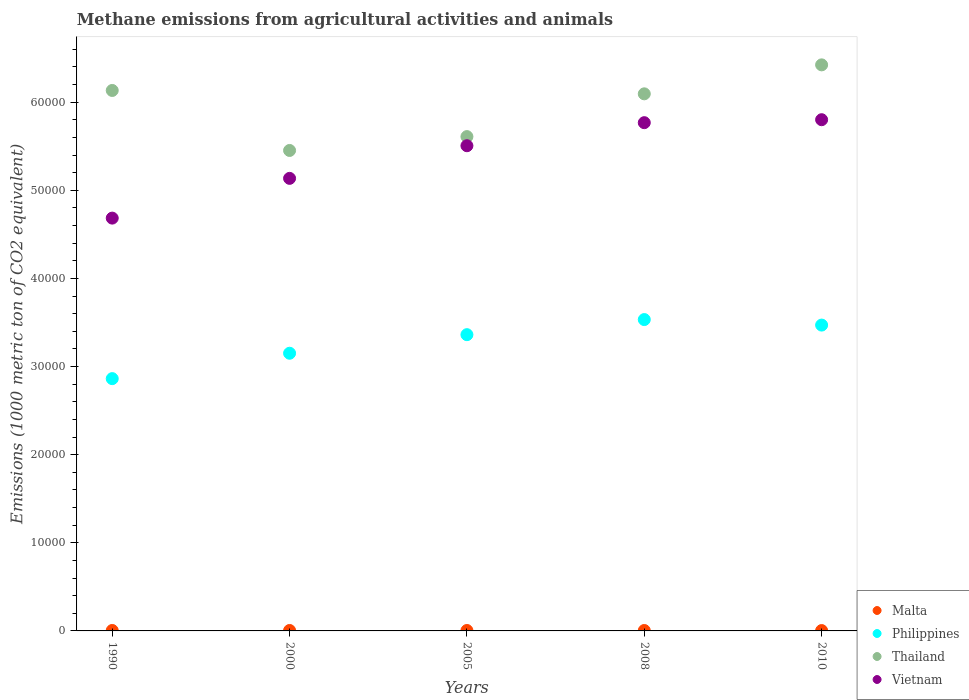How many different coloured dotlines are there?
Make the answer very short. 4. Is the number of dotlines equal to the number of legend labels?
Your answer should be very brief. Yes. What is the amount of methane emitted in Malta in 2008?
Provide a succinct answer. 46.9. Across all years, what is the maximum amount of methane emitted in Philippines?
Offer a terse response. 3.53e+04. Across all years, what is the minimum amount of methane emitted in Vietnam?
Ensure brevity in your answer.  4.68e+04. In which year was the amount of methane emitted in Philippines maximum?
Keep it short and to the point. 2008. What is the total amount of methane emitted in Philippines in the graph?
Provide a short and direct response. 1.64e+05. What is the difference between the amount of methane emitted in Vietnam in 2000 and that in 2010?
Keep it short and to the point. -6656.2. What is the difference between the amount of methane emitted in Philippines in 1990 and the amount of methane emitted in Malta in 2000?
Give a very brief answer. 2.86e+04. What is the average amount of methane emitted in Vietnam per year?
Make the answer very short. 5.38e+04. In the year 2000, what is the difference between the amount of methane emitted in Malta and amount of methane emitted in Vietnam?
Your answer should be very brief. -5.13e+04. What is the ratio of the amount of methane emitted in Malta in 1990 to that in 2008?
Keep it short and to the point. 1.09. Is the amount of methane emitted in Philippines in 1990 less than that in 2008?
Provide a succinct answer. Yes. What is the difference between the highest and the second highest amount of methane emitted in Malta?
Provide a succinct answer. 0.3. What is the difference between the highest and the lowest amount of methane emitted in Malta?
Ensure brevity in your answer.  9.9. In how many years, is the amount of methane emitted in Thailand greater than the average amount of methane emitted in Thailand taken over all years?
Make the answer very short. 3. Is the sum of the amount of methane emitted in Philippines in 1990 and 2000 greater than the maximum amount of methane emitted in Malta across all years?
Offer a very short reply. Yes. Is the amount of methane emitted in Thailand strictly greater than the amount of methane emitted in Malta over the years?
Your answer should be compact. Yes. Is the amount of methane emitted in Vietnam strictly less than the amount of methane emitted in Malta over the years?
Your response must be concise. No. How many years are there in the graph?
Keep it short and to the point. 5. Are the values on the major ticks of Y-axis written in scientific E-notation?
Make the answer very short. No. Does the graph contain any zero values?
Your answer should be compact. No. How many legend labels are there?
Give a very brief answer. 4. What is the title of the graph?
Your answer should be compact. Methane emissions from agricultural activities and animals. What is the label or title of the Y-axis?
Your answer should be compact. Emissions (1000 metric ton of CO2 equivalent). What is the Emissions (1000 metric ton of CO2 equivalent) of Malta in 1990?
Give a very brief answer. 50.9. What is the Emissions (1000 metric ton of CO2 equivalent) in Philippines in 1990?
Make the answer very short. 2.86e+04. What is the Emissions (1000 metric ton of CO2 equivalent) in Thailand in 1990?
Keep it short and to the point. 6.13e+04. What is the Emissions (1000 metric ton of CO2 equivalent) of Vietnam in 1990?
Give a very brief answer. 4.68e+04. What is the Emissions (1000 metric ton of CO2 equivalent) in Malta in 2000?
Offer a terse response. 50.6. What is the Emissions (1000 metric ton of CO2 equivalent) in Philippines in 2000?
Ensure brevity in your answer.  3.15e+04. What is the Emissions (1000 metric ton of CO2 equivalent) in Thailand in 2000?
Keep it short and to the point. 5.45e+04. What is the Emissions (1000 metric ton of CO2 equivalent) in Vietnam in 2000?
Provide a short and direct response. 5.14e+04. What is the Emissions (1000 metric ton of CO2 equivalent) of Malta in 2005?
Provide a short and direct response. 48.2. What is the Emissions (1000 metric ton of CO2 equivalent) in Philippines in 2005?
Offer a very short reply. 3.36e+04. What is the Emissions (1000 metric ton of CO2 equivalent) of Thailand in 2005?
Ensure brevity in your answer.  5.61e+04. What is the Emissions (1000 metric ton of CO2 equivalent) in Vietnam in 2005?
Your response must be concise. 5.51e+04. What is the Emissions (1000 metric ton of CO2 equivalent) in Malta in 2008?
Your response must be concise. 46.9. What is the Emissions (1000 metric ton of CO2 equivalent) of Philippines in 2008?
Offer a terse response. 3.53e+04. What is the Emissions (1000 metric ton of CO2 equivalent) in Thailand in 2008?
Give a very brief answer. 6.10e+04. What is the Emissions (1000 metric ton of CO2 equivalent) in Vietnam in 2008?
Offer a very short reply. 5.77e+04. What is the Emissions (1000 metric ton of CO2 equivalent) in Philippines in 2010?
Make the answer very short. 3.47e+04. What is the Emissions (1000 metric ton of CO2 equivalent) in Thailand in 2010?
Your response must be concise. 6.42e+04. What is the Emissions (1000 metric ton of CO2 equivalent) of Vietnam in 2010?
Keep it short and to the point. 5.80e+04. Across all years, what is the maximum Emissions (1000 metric ton of CO2 equivalent) in Malta?
Your response must be concise. 50.9. Across all years, what is the maximum Emissions (1000 metric ton of CO2 equivalent) in Philippines?
Your answer should be compact. 3.53e+04. Across all years, what is the maximum Emissions (1000 metric ton of CO2 equivalent) in Thailand?
Provide a short and direct response. 6.42e+04. Across all years, what is the maximum Emissions (1000 metric ton of CO2 equivalent) in Vietnam?
Offer a very short reply. 5.80e+04. Across all years, what is the minimum Emissions (1000 metric ton of CO2 equivalent) of Philippines?
Your response must be concise. 2.86e+04. Across all years, what is the minimum Emissions (1000 metric ton of CO2 equivalent) in Thailand?
Your answer should be compact. 5.45e+04. Across all years, what is the minimum Emissions (1000 metric ton of CO2 equivalent) in Vietnam?
Your answer should be compact. 4.68e+04. What is the total Emissions (1000 metric ton of CO2 equivalent) of Malta in the graph?
Keep it short and to the point. 237.6. What is the total Emissions (1000 metric ton of CO2 equivalent) of Philippines in the graph?
Make the answer very short. 1.64e+05. What is the total Emissions (1000 metric ton of CO2 equivalent) in Thailand in the graph?
Provide a short and direct response. 2.97e+05. What is the total Emissions (1000 metric ton of CO2 equivalent) of Vietnam in the graph?
Ensure brevity in your answer.  2.69e+05. What is the difference between the Emissions (1000 metric ton of CO2 equivalent) of Malta in 1990 and that in 2000?
Your response must be concise. 0.3. What is the difference between the Emissions (1000 metric ton of CO2 equivalent) of Philippines in 1990 and that in 2000?
Offer a very short reply. -2881.3. What is the difference between the Emissions (1000 metric ton of CO2 equivalent) of Thailand in 1990 and that in 2000?
Offer a very short reply. 6808.4. What is the difference between the Emissions (1000 metric ton of CO2 equivalent) of Vietnam in 1990 and that in 2000?
Provide a succinct answer. -4511. What is the difference between the Emissions (1000 metric ton of CO2 equivalent) of Malta in 1990 and that in 2005?
Ensure brevity in your answer.  2.7. What is the difference between the Emissions (1000 metric ton of CO2 equivalent) in Philippines in 1990 and that in 2005?
Offer a very short reply. -4989.5. What is the difference between the Emissions (1000 metric ton of CO2 equivalent) of Thailand in 1990 and that in 2005?
Offer a very short reply. 5235.2. What is the difference between the Emissions (1000 metric ton of CO2 equivalent) of Vietnam in 1990 and that in 2005?
Your response must be concise. -8213.9. What is the difference between the Emissions (1000 metric ton of CO2 equivalent) in Philippines in 1990 and that in 2008?
Your answer should be compact. -6703.2. What is the difference between the Emissions (1000 metric ton of CO2 equivalent) of Thailand in 1990 and that in 2008?
Make the answer very short. 381.9. What is the difference between the Emissions (1000 metric ton of CO2 equivalent) of Vietnam in 1990 and that in 2008?
Ensure brevity in your answer.  -1.08e+04. What is the difference between the Emissions (1000 metric ton of CO2 equivalent) in Malta in 1990 and that in 2010?
Ensure brevity in your answer.  9.9. What is the difference between the Emissions (1000 metric ton of CO2 equivalent) of Philippines in 1990 and that in 2010?
Keep it short and to the point. -6077.5. What is the difference between the Emissions (1000 metric ton of CO2 equivalent) in Thailand in 1990 and that in 2010?
Your response must be concise. -2905.8. What is the difference between the Emissions (1000 metric ton of CO2 equivalent) in Vietnam in 1990 and that in 2010?
Provide a short and direct response. -1.12e+04. What is the difference between the Emissions (1000 metric ton of CO2 equivalent) in Philippines in 2000 and that in 2005?
Make the answer very short. -2108.2. What is the difference between the Emissions (1000 metric ton of CO2 equivalent) of Thailand in 2000 and that in 2005?
Ensure brevity in your answer.  -1573.2. What is the difference between the Emissions (1000 metric ton of CO2 equivalent) of Vietnam in 2000 and that in 2005?
Your response must be concise. -3702.9. What is the difference between the Emissions (1000 metric ton of CO2 equivalent) of Philippines in 2000 and that in 2008?
Make the answer very short. -3821.9. What is the difference between the Emissions (1000 metric ton of CO2 equivalent) of Thailand in 2000 and that in 2008?
Offer a very short reply. -6426.5. What is the difference between the Emissions (1000 metric ton of CO2 equivalent) of Vietnam in 2000 and that in 2008?
Your answer should be compact. -6319.4. What is the difference between the Emissions (1000 metric ton of CO2 equivalent) in Philippines in 2000 and that in 2010?
Provide a short and direct response. -3196.2. What is the difference between the Emissions (1000 metric ton of CO2 equivalent) of Thailand in 2000 and that in 2010?
Provide a succinct answer. -9714.2. What is the difference between the Emissions (1000 metric ton of CO2 equivalent) of Vietnam in 2000 and that in 2010?
Keep it short and to the point. -6656.2. What is the difference between the Emissions (1000 metric ton of CO2 equivalent) of Philippines in 2005 and that in 2008?
Provide a short and direct response. -1713.7. What is the difference between the Emissions (1000 metric ton of CO2 equivalent) in Thailand in 2005 and that in 2008?
Give a very brief answer. -4853.3. What is the difference between the Emissions (1000 metric ton of CO2 equivalent) in Vietnam in 2005 and that in 2008?
Offer a very short reply. -2616.5. What is the difference between the Emissions (1000 metric ton of CO2 equivalent) in Philippines in 2005 and that in 2010?
Offer a terse response. -1088. What is the difference between the Emissions (1000 metric ton of CO2 equivalent) in Thailand in 2005 and that in 2010?
Your response must be concise. -8141. What is the difference between the Emissions (1000 metric ton of CO2 equivalent) of Vietnam in 2005 and that in 2010?
Your response must be concise. -2953.3. What is the difference between the Emissions (1000 metric ton of CO2 equivalent) of Philippines in 2008 and that in 2010?
Make the answer very short. 625.7. What is the difference between the Emissions (1000 metric ton of CO2 equivalent) of Thailand in 2008 and that in 2010?
Offer a very short reply. -3287.7. What is the difference between the Emissions (1000 metric ton of CO2 equivalent) of Vietnam in 2008 and that in 2010?
Provide a succinct answer. -336.8. What is the difference between the Emissions (1000 metric ton of CO2 equivalent) in Malta in 1990 and the Emissions (1000 metric ton of CO2 equivalent) in Philippines in 2000?
Your response must be concise. -3.15e+04. What is the difference between the Emissions (1000 metric ton of CO2 equivalent) of Malta in 1990 and the Emissions (1000 metric ton of CO2 equivalent) of Thailand in 2000?
Give a very brief answer. -5.45e+04. What is the difference between the Emissions (1000 metric ton of CO2 equivalent) of Malta in 1990 and the Emissions (1000 metric ton of CO2 equivalent) of Vietnam in 2000?
Provide a succinct answer. -5.13e+04. What is the difference between the Emissions (1000 metric ton of CO2 equivalent) in Philippines in 1990 and the Emissions (1000 metric ton of CO2 equivalent) in Thailand in 2000?
Make the answer very short. -2.59e+04. What is the difference between the Emissions (1000 metric ton of CO2 equivalent) in Philippines in 1990 and the Emissions (1000 metric ton of CO2 equivalent) in Vietnam in 2000?
Give a very brief answer. -2.27e+04. What is the difference between the Emissions (1000 metric ton of CO2 equivalent) in Thailand in 1990 and the Emissions (1000 metric ton of CO2 equivalent) in Vietnam in 2000?
Offer a terse response. 9974.7. What is the difference between the Emissions (1000 metric ton of CO2 equivalent) in Malta in 1990 and the Emissions (1000 metric ton of CO2 equivalent) in Philippines in 2005?
Provide a short and direct response. -3.36e+04. What is the difference between the Emissions (1000 metric ton of CO2 equivalent) in Malta in 1990 and the Emissions (1000 metric ton of CO2 equivalent) in Thailand in 2005?
Your answer should be compact. -5.60e+04. What is the difference between the Emissions (1000 metric ton of CO2 equivalent) of Malta in 1990 and the Emissions (1000 metric ton of CO2 equivalent) of Vietnam in 2005?
Provide a succinct answer. -5.50e+04. What is the difference between the Emissions (1000 metric ton of CO2 equivalent) of Philippines in 1990 and the Emissions (1000 metric ton of CO2 equivalent) of Thailand in 2005?
Offer a terse response. -2.75e+04. What is the difference between the Emissions (1000 metric ton of CO2 equivalent) in Philippines in 1990 and the Emissions (1000 metric ton of CO2 equivalent) in Vietnam in 2005?
Your answer should be very brief. -2.64e+04. What is the difference between the Emissions (1000 metric ton of CO2 equivalent) in Thailand in 1990 and the Emissions (1000 metric ton of CO2 equivalent) in Vietnam in 2005?
Offer a terse response. 6271.8. What is the difference between the Emissions (1000 metric ton of CO2 equivalent) of Malta in 1990 and the Emissions (1000 metric ton of CO2 equivalent) of Philippines in 2008?
Your response must be concise. -3.53e+04. What is the difference between the Emissions (1000 metric ton of CO2 equivalent) of Malta in 1990 and the Emissions (1000 metric ton of CO2 equivalent) of Thailand in 2008?
Ensure brevity in your answer.  -6.09e+04. What is the difference between the Emissions (1000 metric ton of CO2 equivalent) in Malta in 1990 and the Emissions (1000 metric ton of CO2 equivalent) in Vietnam in 2008?
Provide a succinct answer. -5.76e+04. What is the difference between the Emissions (1000 metric ton of CO2 equivalent) of Philippines in 1990 and the Emissions (1000 metric ton of CO2 equivalent) of Thailand in 2008?
Provide a succinct answer. -3.23e+04. What is the difference between the Emissions (1000 metric ton of CO2 equivalent) in Philippines in 1990 and the Emissions (1000 metric ton of CO2 equivalent) in Vietnam in 2008?
Keep it short and to the point. -2.90e+04. What is the difference between the Emissions (1000 metric ton of CO2 equivalent) in Thailand in 1990 and the Emissions (1000 metric ton of CO2 equivalent) in Vietnam in 2008?
Offer a very short reply. 3655.3. What is the difference between the Emissions (1000 metric ton of CO2 equivalent) of Malta in 1990 and the Emissions (1000 metric ton of CO2 equivalent) of Philippines in 2010?
Ensure brevity in your answer.  -3.47e+04. What is the difference between the Emissions (1000 metric ton of CO2 equivalent) in Malta in 1990 and the Emissions (1000 metric ton of CO2 equivalent) in Thailand in 2010?
Offer a terse response. -6.42e+04. What is the difference between the Emissions (1000 metric ton of CO2 equivalent) in Malta in 1990 and the Emissions (1000 metric ton of CO2 equivalent) in Vietnam in 2010?
Your response must be concise. -5.80e+04. What is the difference between the Emissions (1000 metric ton of CO2 equivalent) in Philippines in 1990 and the Emissions (1000 metric ton of CO2 equivalent) in Thailand in 2010?
Your answer should be very brief. -3.56e+04. What is the difference between the Emissions (1000 metric ton of CO2 equivalent) of Philippines in 1990 and the Emissions (1000 metric ton of CO2 equivalent) of Vietnam in 2010?
Your answer should be compact. -2.94e+04. What is the difference between the Emissions (1000 metric ton of CO2 equivalent) in Thailand in 1990 and the Emissions (1000 metric ton of CO2 equivalent) in Vietnam in 2010?
Offer a very short reply. 3318.5. What is the difference between the Emissions (1000 metric ton of CO2 equivalent) in Malta in 2000 and the Emissions (1000 metric ton of CO2 equivalent) in Philippines in 2005?
Offer a terse response. -3.36e+04. What is the difference between the Emissions (1000 metric ton of CO2 equivalent) of Malta in 2000 and the Emissions (1000 metric ton of CO2 equivalent) of Thailand in 2005?
Ensure brevity in your answer.  -5.60e+04. What is the difference between the Emissions (1000 metric ton of CO2 equivalent) in Malta in 2000 and the Emissions (1000 metric ton of CO2 equivalent) in Vietnam in 2005?
Provide a short and direct response. -5.50e+04. What is the difference between the Emissions (1000 metric ton of CO2 equivalent) of Philippines in 2000 and the Emissions (1000 metric ton of CO2 equivalent) of Thailand in 2005?
Make the answer very short. -2.46e+04. What is the difference between the Emissions (1000 metric ton of CO2 equivalent) in Philippines in 2000 and the Emissions (1000 metric ton of CO2 equivalent) in Vietnam in 2005?
Make the answer very short. -2.35e+04. What is the difference between the Emissions (1000 metric ton of CO2 equivalent) in Thailand in 2000 and the Emissions (1000 metric ton of CO2 equivalent) in Vietnam in 2005?
Offer a terse response. -536.6. What is the difference between the Emissions (1000 metric ton of CO2 equivalent) in Malta in 2000 and the Emissions (1000 metric ton of CO2 equivalent) in Philippines in 2008?
Offer a terse response. -3.53e+04. What is the difference between the Emissions (1000 metric ton of CO2 equivalent) of Malta in 2000 and the Emissions (1000 metric ton of CO2 equivalent) of Thailand in 2008?
Give a very brief answer. -6.09e+04. What is the difference between the Emissions (1000 metric ton of CO2 equivalent) in Malta in 2000 and the Emissions (1000 metric ton of CO2 equivalent) in Vietnam in 2008?
Give a very brief answer. -5.76e+04. What is the difference between the Emissions (1000 metric ton of CO2 equivalent) of Philippines in 2000 and the Emissions (1000 metric ton of CO2 equivalent) of Thailand in 2008?
Your answer should be compact. -2.94e+04. What is the difference between the Emissions (1000 metric ton of CO2 equivalent) in Philippines in 2000 and the Emissions (1000 metric ton of CO2 equivalent) in Vietnam in 2008?
Provide a succinct answer. -2.62e+04. What is the difference between the Emissions (1000 metric ton of CO2 equivalent) in Thailand in 2000 and the Emissions (1000 metric ton of CO2 equivalent) in Vietnam in 2008?
Give a very brief answer. -3153.1. What is the difference between the Emissions (1000 metric ton of CO2 equivalent) in Malta in 2000 and the Emissions (1000 metric ton of CO2 equivalent) in Philippines in 2010?
Provide a succinct answer. -3.47e+04. What is the difference between the Emissions (1000 metric ton of CO2 equivalent) in Malta in 2000 and the Emissions (1000 metric ton of CO2 equivalent) in Thailand in 2010?
Your answer should be compact. -6.42e+04. What is the difference between the Emissions (1000 metric ton of CO2 equivalent) of Malta in 2000 and the Emissions (1000 metric ton of CO2 equivalent) of Vietnam in 2010?
Offer a very short reply. -5.80e+04. What is the difference between the Emissions (1000 metric ton of CO2 equivalent) in Philippines in 2000 and the Emissions (1000 metric ton of CO2 equivalent) in Thailand in 2010?
Provide a succinct answer. -3.27e+04. What is the difference between the Emissions (1000 metric ton of CO2 equivalent) of Philippines in 2000 and the Emissions (1000 metric ton of CO2 equivalent) of Vietnam in 2010?
Your response must be concise. -2.65e+04. What is the difference between the Emissions (1000 metric ton of CO2 equivalent) in Thailand in 2000 and the Emissions (1000 metric ton of CO2 equivalent) in Vietnam in 2010?
Provide a succinct answer. -3489.9. What is the difference between the Emissions (1000 metric ton of CO2 equivalent) in Malta in 2005 and the Emissions (1000 metric ton of CO2 equivalent) in Philippines in 2008?
Provide a succinct answer. -3.53e+04. What is the difference between the Emissions (1000 metric ton of CO2 equivalent) of Malta in 2005 and the Emissions (1000 metric ton of CO2 equivalent) of Thailand in 2008?
Provide a succinct answer. -6.09e+04. What is the difference between the Emissions (1000 metric ton of CO2 equivalent) of Malta in 2005 and the Emissions (1000 metric ton of CO2 equivalent) of Vietnam in 2008?
Your response must be concise. -5.76e+04. What is the difference between the Emissions (1000 metric ton of CO2 equivalent) in Philippines in 2005 and the Emissions (1000 metric ton of CO2 equivalent) in Thailand in 2008?
Ensure brevity in your answer.  -2.73e+04. What is the difference between the Emissions (1000 metric ton of CO2 equivalent) in Philippines in 2005 and the Emissions (1000 metric ton of CO2 equivalent) in Vietnam in 2008?
Give a very brief answer. -2.41e+04. What is the difference between the Emissions (1000 metric ton of CO2 equivalent) in Thailand in 2005 and the Emissions (1000 metric ton of CO2 equivalent) in Vietnam in 2008?
Provide a short and direct response. -1579.9. What is the difference between the Emissions (1000 metric ton of CO2 equivalent) in Malta in 2005 and the Emissions (1000 metric ton of CO2 equivalent) in Philippines in 2010?
Provide a short and direct response. -3.47e+04. What is the difference between the Emissions (1000 metric ton of CO2 equivalent) in Malta in 2005 and the Emissions (1000 metric ton of CO2 equivalent) in Thailand in 2010?
Make the answer very short. -6.42e+04. What is the difference between the Emissions (1000 metric ton of CO2 equivalent) of Malta in 2005 and the Emissions (1000 metric ton of CO2 equivalent) of Vietnam in 2010?
Give a very brief answer. -5.80e+04. What is the difference between the Emissions (1000 metric ton of CO2 equivalent) in Philippines in 2005 and the Emissions (1000 metric ton of CO2 equivalent) in Thailand in 2010?
Offer a terse response. -3.06e+04. What is the difference between the Emissions (1000 metric ton of CO2 equivalent) of Philippines in 2005 and the Emissions (1000 metric ton of CO2 equivalent) of Vietnam in 2010?
Provide a short and direct response. -2.44e+04. What is the difference between the Emissions (1000 metric ton of CO2 equivalent) in Thailand in 2005 and the Emissions (1000 metric ton of CO2 equivalent) in Vietnam in 2010?
Your answer should be compact. -1916.7. What is the difference between the Emissions (1000 metric ton of CO2 equivalent) in Malta in 2008 and the Emissions (1000 metric ton of CO2 equivalent) in Philippines in 2010?
Your response must be concise. -3.47e+04. What is the difference between the Emissions (1000 metric ton of CO2 equivalent) of Malta in 2008 and the Emissions (1000 metric ton of CO2 equivalent) of Thailand in 2010?
Ensure brevity in your answer.  -6.42e+04. What is the difference between the Emissions (1000 metric ton of CO2 equivalent) of Malta in 2008 and the Emissions (1000 metric ton of CO2 equivalent) of Vietnam in 2010?
Your answer should be compact. -5.80e+04. What is the difference between the Emissions (1000 metric ton of CO2 equivalent) of Philippines in 2008 and the Emissions (1000 metric ton of CO2 equivalent) of Thailand in 2010?
Provide a short and direct response. -2.89e+04. What is the difference between the Emissions (1000 metric ton of CO2 equivalent) in Philippines in 2008 and the Emissions (1000 metric ton of CO2 equivalent) in Vietnam in 2010?
Give a very brief answer. -2.27e+04. What is the difference between the Emissions (1000 metric ton of CO2 equivalent) in Thailand in 2008 and the Emissions (1000 metric ton of CO2 equivalent) in Vietnam in 2010?
Keep it short and to the point. 2936.6. What is the average Emissions (1000 metric ton of CO2 equivalent) in Malta per year?
Ensure brevity in your answer.  47.52. What is the average Emissions (1000 metric ton of CO2 equivalent) in Philippines per year?
Your answer should be compact. 3.28e+04. What is the average Emissions (1000 metric ton of CO2 equivalent) of Thailand per year?
Give a very brief answer. 5.94e+04. What is the average Emissions (1000 metric ton of CO2 equivalent) of Vietnam per year?
Your response must be concise. 5.38e+04. In the year 1990, what is the difference between the Emissions (1000 metric ton of CO2 equivalent) of Malta and Emissions (1000 metric ton of CO2 equivalent) of Philippines?
Provide a short and direct response. -2.86e+04. In the year 1990, what is the difference between the Emissions (1000 metric ton of CO2 equivalent) of Malta and Emissions (1000 metric ton of CO2 equivalent) of Thailand?
Offer a terse response. -6.13e+04. In the year 1990, what is the difference between the Emissions (1000 metric ton of CO2 equivalent) in Malta and Emissions (1000 metric ton of CO2 equivalent) in Vietnam?
Provide a short and direct response. -4.68e+04. In the year 1990, what is the difference between the Emissions (1000 metric ton of CO2 equivalent) of Philippines and Emissions (1000 metric ton of CO2 equivalent) of Thailand?
Your answer should be very brief. -3.27e+04. In the year 1990, what is the difference between the Emissions (1000 metric ton of CO2 equivalent) in Philippines and Emissions (1000 metric ton of CO2 equivalent) in Vietnam?
Give a very brief answer. -1.82e+04. In the year 1990, what is the difference between the Emissions (1000 metric ton of CO2 equivalent) in Thailand and Emissions (1000 metric ton of CO2 equivalent) in Vietnam?
Make the answer very short. 1.45e+04. In the year 2000, what is the difference between the Emissions (1000 metric ton of CO2 equivalent) in Malta and Emissions (1000 metric ton of CO2 equivalent) in Philippines?
Give a very brief answer. -3.15e+04. In the year 2000, what is the difference between the Emissions (1000 metric ton of CO2 equivalent) in Malta and Emissions (1000 metric ton of CO2 equivalent) in Thailand?
Your answer should be very brief. -5.45e+04. In the year 2000, what is the difference between the Emissions (1000 metric ton of CO2 equivalent) of Malta and Emissions (1000 metric ton of CO2 equivalent) of Vietnam?
Provide a short and direct response. -5.13e+04. In the year 2000, what is the difference between the Emissions (1000 metric ton of CO2 equivalent) in Philippines and Emissions (1000 metric ton of CO2 equivalent) in Thailand?
Provide a short and direct response. -2.30e+04. In the year 2000, what is the difference between the Emissions (1000 metric ton of CO2 equivalent) of Philippines and Emissions (1000 metric ton of CO2 equivalent) of Vietnam?
Keep it short and to the point. -1.98e+04. In the year 2000, what is the difference between the Emissions (1000 metric ton of CO2 equivalent) in Thailand and Emissions (1000 metric ton of CO2 equivalent) in Vietnam?
Offer a terse response. 3166.3. In the year 2005, what is the difference between the Emissions (1000 metric ton of CO2 equivalent) of Malta and Emissions (1000 metric ton of CO2 equivalent) of Philippines?
Your answer should be compact. -3.36e+04. In the year 2005, what is the difference between the Emissions (1000 metric ton of CO2 equivalent) in Malta and Emissions (1000 metric ton of CO2 equivalent) in Thailand?
Make the answer very short. -5.60e+04. In the year 2005, what is the difference between the Emissions (1000 metric ton of CO2 equivalent) in Malta and Emissions (1000 metric ton of CO2 equivalent) in Vietnam?
Offer a very short reply. -5.50e+04. In the year 2005, what is the difference between the Emissions (1000 metric ton of CO2 equivalent) in Philippines and Emissions (1000 metric ton of CO2 equivalent) in Thailand?
Keep it short and to the point. -2.25e+04. In the year 2005, what is the difference between the Emissions (1000 metric ton of CO2 equivalent) in Philippines and Emissions (1000 metric ton of CO2 equivalent) in Vietnam?
Provide a short and direct response. -2.14e+04. In the year 2005, what is the difference between the Emissions (1000 metric ton of CO2 equivalent) in Thailand and Emissions (1000 metric ton of CO2 equivalent) in Vietnam?
Your answer should be compact. 1036.6. In the year 2008, what is the difference between the Emissions (1000 metric ton of CO2 equivalent) in Malta and Emissions (1000 metric ton of CO2 equivalent) in Philippines?
Your answer should be compact. -3.53e+04. In the year 2008, what is the difference between the Emissions (1000 metric ton of CO2 equivalent) of Malta and Emissions (1000 metric ton of CO2 equivalent) of Thailand?
Provide a succinct answer. -6.09e+04. In the year 2008, what is the difference between the Emissions (1000 metric ton of CO2 equivalent) in Malta and Emissions (1000 metric ton of CO2 equivalent) in Vietnam?
Provide a short and direct response. -5.76e+04. In the year 2008, what is the difference between the Emissions (1000 metric ton of CO2 equivalent) of Philippines and Emissions (1000 metric ton of CO2 equivalent) of Thailand?
Provide a succinct answer. -2.56e+04. In the year 2008, what is the difference between the Emissions (1000 metric ton of CO2 equivalent) of Philippines and Emissions (1000 metric ton of CO2 equivalent) of Vietnam?
Provide a short and direct response. -2.23e+04. In the year 2008, what is the difference between the Emissions (1000 metric ton of CO2 equivalent) in Thailand and Emissions (1000 metric ton of CO2 equivalent) in Vietnam?
Provide a succinct answer. 3273.4. In the year 2010, what is the difference between the Emissions (1000 metric ton of CO2 equivalent) in Malta and Emissions (1000 metric ton of CO2 equivalent) in Philippines?
Offer a terse response. -3.47e+04. In the year 2010, what is the difference between the Emissions (1000 metric ton of CO2 equivalent) of Malta and Emissions (1000 metric ton of CO2 equivalent) of Thailand?
Offer a terse response. -6.42e+04. In the year 2010, what is the difference between the Emissions (1000 metric ton of CO2 equivalent) of Malta and Emissions (1000 metric ton of CO2 equivalent) of Vietnam?
Ensure brevity in your answer.  -5.80e+04. In the year 2010, what is the difference between the Emissions (1000 metric ton of CO2 equivalent) in Philippines and Emissions (1000 metric ton of CO2 equivalent) in Thailand?
Your answer should be very brief. -2.95e+04. In the year 2010, what is the difference between the Emissions (1000 metric ton of CO2 equivalent) in Philippines and Emissions (1000 metric ton of CO2 equivalent) in Vietnam?
Provide a short and direct response. -2.33e+04. In the year 2010, what is the difference between the Emissions (1000 metric ton of CO2 equivalent) in Thailand and Emissions (1000 metric ton of CO2 equivalent) in Vietnam?
Provide a short and direct response. 6224.3. What is the ratio of the Emissions (1000 metric ton of CO2 equivalent) of Malta in 1990 to that in 2000?
Make the answer very short. 1.01. What is the ratio of the Emissions (1000 metric ton of CO2 equivalent) in Philippines in 1990 to that in 2000?
Give a very brief answer. 0.91. What is the ratio of the Emissions (1000 metric ton of CO2 equivalent) of Thailand in 1990 to that in 2000?
Ensure brevity in your answer.  1.12. What is the ratio of the Emissions (1000 metric ton of CO2 equivalent) of Vietnam in 1990 to that in 2000?
Make the answer very short. 0.91. What is the ratio of the Emissions (1000 metric ton of CO2 equivalent) of Malta in 1990 to that in 2005?
Your response must be concise. 1.06. What is the ratio of the Emissions (1000 metric ton of CO2 equivalent) in Philippines in 1990 to that in 2005?
Keep it short and to the point. 0.85. What is the ratio of the Emissions (1000 metric ton of CO2 equivalent) of Thailand in 1990 to that in 2005?
Your answer should be very brief. 1.09. What is the ratio of the Emissions (1000 metric ton of CO2 equivalent) in Vietnam in 1990 to that in 2005?
Ensure brevity in your answer.  0.85. What is the ratio of the Emissions (1000 metric ton of CO2 equivalent) in Malta in 1990 to that in 2008?
Provide a succinct answer. 1.09. What is the ratio of the Emissions (1000 metric ton of CO2 equivalent) of Philippines in 1990 to that in 2008?
Your response must be concise. 0.81. What is the ratio of the Emissions (1000 metric ton of CO2 equivalent) in Vietnam in 1990 to that in 2008?
Give a very brief answer. 0.81. What is the ratio of the Emissions (1000 metric ton of CO2 equivalent) of Malta in 1990 to that in 2010?
Your response must be concise. 1.24. What is the ratio of the Emissions (1000 metric ton of CO2 equivalent) in Philippines in 1990 to that in 2010?
Keep it short and to the point. 0.82. What is the ratio of the Emissions (1000 metric ton of CO2 equivalent) in Thailand in 1990 to that in 2010?
Give a very brief answer. 0.95. What is the ratio of the Emissions (1000 metric ton of CO2 equivalent) of Vietnam in 1990 to that in 2010?
Give a very brief answer. 0.81. What is the ratio of the Emissions (1000 metric ton of CO2 equivalent) of Malta in 2000 to that in 2005?
Your answer should be very brief. 1.05. What is the ratio of the Emissions (1000 metric ton of CO2 equivalent) in Philippines in 2000 to that in 2005?
Keep it short and to the point. 0.94. What is the ratio of the Emissions (1000 metric ton of CO2 equivalent) in Vietnam in 2000 to that in 2005?
Your answer should be very brief. 0.93. What is the ratio of the Emissions (1000 metric ton of CO2 equivalent) of Malta in 2000 to that in 2008?
Make the answer very short. 1.08. What is the ratio of the Emissions (1000 metric ton of CO2 equivalent) in Philippines in 2000 to that in 2008?
Your answer should be compact. 0.89. What is the ratio of the Emissions (1000 metric ton of CO2 equivalent) in Thailand in 2000 to that in 2008?
Your answer should be very brief. 0.89. What is the ratio of the Emissions (1000 metric ton of CO2 equivalent) in Vietnam in 2000 to that in 2008?
Ensure brevity in your answer.  0.89. What is the ratio of the Emissions (1000 metric ton of CO2 equivalent) of Malta in 2000 to that in 2010?
Your answer should be very brief. 1.23. What is the ratio of the Emissions (1000 metric ton of CO2 equivalent) of Philippines in 2000 to that in 2010?
Provide a succinct answer. 0.91. What is the ratio of the Emissions (1000 metric ton of CO2 equivalent) of Thailand in 2000 to that in 2010?
Your response must be concise. 0.85. What is the ratio of the Emissions (1000 metric ton of CO2 equivalent) in Vietnam in 2000 to that in 2010?
Offer a very short reply. 0.89. What is the ratio of the Emissions (1000 metric ton of CO2 equivalent) in Malta in 2005 to that in 2008?
Keep it short and to the point. 1.03. What is the ratio of the Emissions (1000 metric ton of CO2 equivalent) in Philippines in 2005 to that in 2008?
Ensure brevity in your answer.  0.95. What is the ratio of the Emissions (1000 metric ton of CO2 equivalent) of Thailand in 2005 to that in 2008?
Your answer should be very brief. 0.92. What is the ratio of the Emissions (1000 metric ton of CO2 equivalent) of Vietnam in 2005 to that in 2008?
Make the answer very short. 0.95. What is the ratio of the Emissions (1000 metric ton of CO2 equivalent) of Malta in 2005 to that in 2010?
Your answer should be very brief. 1.18. What is the ratio of the Emissions (1000 metric ton of CO2 equivalent) of Philippines in 2005 to that in 2010?
Provide a short and direct response. 0.97. What is the ratio of the Emissions (1000 metric ton of CO2 equivalent) of Thailand in 2005 to that in 2010?
Make the answer very short. 0.87. What is the ratio of the Emissions (1000 metric ton of CO2 equivalent) of Vietnam in 2005 to that in 2010?
Give a very brief answer. 0.95. What is the ratio of the Emissions (1000 metric ton of CO2 equivalent) of Malta in 2008 to that in 2010?
Provide a short and direct response. 1.14. What is the ratio of the Emissions (1000 metric ton of CO2 equivalent) in Thailand in 2008 to that in 2010?
Make the answer very short. 0.95. What is the ratio of the Emissions (1000 metric ton of CO2 equivalent) in Vietnam in 2008 to that in 2010?
Provide a short and direct response. 0.99. What is the difference between the highest and the second highest Emissions (1000 metric ton of CO2 equivalent) of Philippines?
Keep it short and to the point. 625.7. What is the difference between the highest and the second highest Emissions (1000 metric ton of CO2 equivalent) in Thailand?
Provide a short and direct response. 2905.8. What is the difference between the highest and the second highest Emissions (1000 metric ton of CO2 equivalent) of Vietnam?
Your answer should be compact. 336.8. What is the difference between the highest and the lowest Emissions (1000 metric ton of CO2 equivalent) of Philippines?
Offer a very short reply. 6703.2. What is the difference between the highest and the lowest Emissions (1000 metric ton of CO2 equivalent) of Thailand?
Your answer should be compact. 9714.2. What is the difference between the highest and the lowest Emissions (1000 metric ton of CO2 equivalent) in Vietnam?
Make the answer very short. 1.12e+04. 